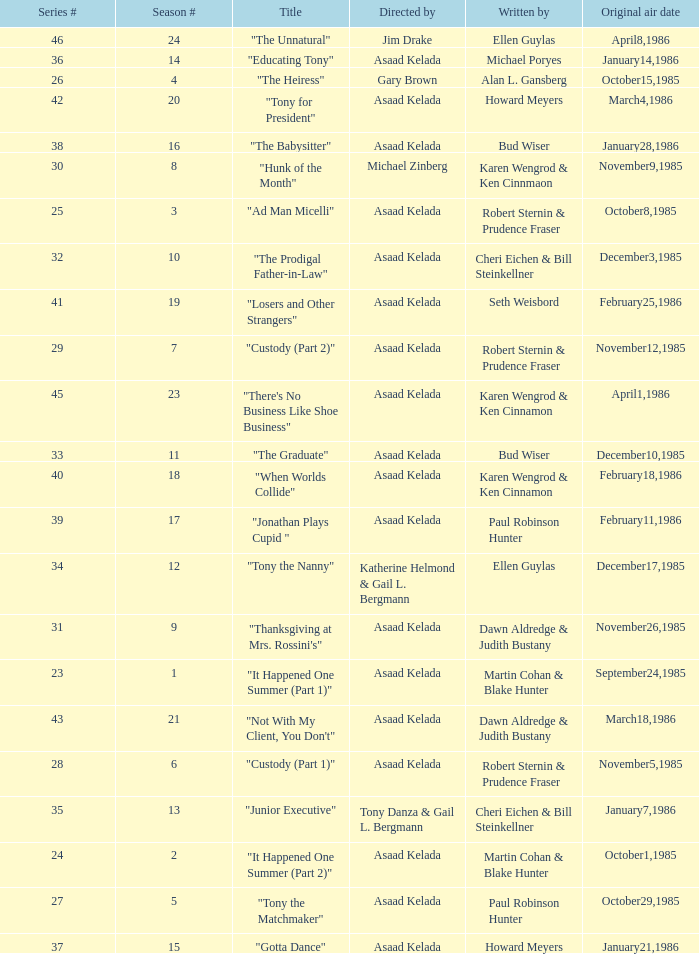Would you be able to parse every entry in this table? {'header': ['Series #', 'Season #', 'Title', 'Directed by', 'Written by', 'Original air date'], 'rows': [['46', '24', '"The Unnatural"', 'Jim Drake', 'Ellen Guylas', 'April8,1986'], ['36', '14', '"Educating Tony"', 'Asaad Kelada', 'Michael Poryes', 'January14,1986'], ['26', '4', '"The Heiress"', 'Gary Brown', 'Alan L. Gansberg', 'October15,1985'], ['42', '20', '"Tony for President"', 'Asaad Kelada', 'Howard Meyers', 'March4,1986'], ['38', '16', '"The Babysitter"', 'Asaad Kelada', 'Bud Wiser', 'January28,1986'], ['30', '8', '"Hunk of the Month"', 'Michael Zinberg', 'Karen Wengrod & Ken Cinnmaon', 'November9,1985'], ['25', '3', '"Ad Man Micelli"', 'Asaad Kelada', 'Robert Sternin & Prudence Fraser', 'October8,1985'], ['32', '10', '"The Prodigal Father-in-Law"', 'Asaad Kelada', 'Cheri Eichen & Bill Steinkellner', 'December3,1985'], ['41', '19', '"Losers and Other Strangers"', 'Asaad Kelada', 'Seth Weisbord', 'February25,1986'], ['29', '7', '"Custody (Part 2)"', 'Asaad Kelada', 'Robert Sternin & Prudence Fraser', 'November12,1985'], ['45', '23', '"There\'s No Business Like Shoe Business"', 'Asaad Kelada', 'Karen Wengrod & Ken Cinnamon', 'April1,1986'], ['33', '11', '"The Graduate"', 'Asaad Kelada', 'Bud Wiser', 'December10,1985'], ['40', '18', '"When Worlds Collide"', 'Asaad Kelada', 'Karen Wengrod & Ken Cinnamon', 'February18,1986'], ['39', '17', '"Jonathan Plays Cupid "', 'Asaad Kelada', 'Paul Robinson Hunter', 'February11,1986'], ['34', '12', '"Tony the Nanny"', 'Katherine Helmond & Gail L. Bergmann', 'Ellen Guylas', 'December17,1985'], ['31', '9', '"Thanksgiving at Mrs. Rossini\'s"', 'Asaad Kelada', 'Dawn Aldredge & Judith Bustany', 'November26,1985'], ['23', '1', '"It Happened One Summer (Part 1)"', 'Asaad Kelada', 'Martin Cohan & Blake Hunter', 'September24,1985'], ['43', '21', '"Not With My Client, You Don\'t"', 'Asaad Kelada', 'Dawn Aldredge & Judith Bustany', 'March18,1986'], ['28', '6', '"Custody (Part 1)"', 'Asaad Kelada', 'Robert Sternin & Prudence Fraser', 'November5,1985'], ['35', '13', '"Junior Executive"', 'Tony Danza & Gail L. Bergmann', 'Cheri Eichen & Bill Steinkellner', 'January7,1986'], ['24', '2', '"It Happened One Summer (Part 2)"', 'Asaad Kelada', 'Martin Cohan & Blake Hunter', 'October1,1985'], ['27', '5', '"Tony the Matchmaker"', 'Asaad Kelada', 'Paul Robinson Hunter', 'October29,1985'], ['37', '15', '"Gotta Dance"', 'Asaad Kelada', 'Howard Meyers', 'January21,1986']]} What is the season where the episode "when worlds collide" was shown? 18.0. 